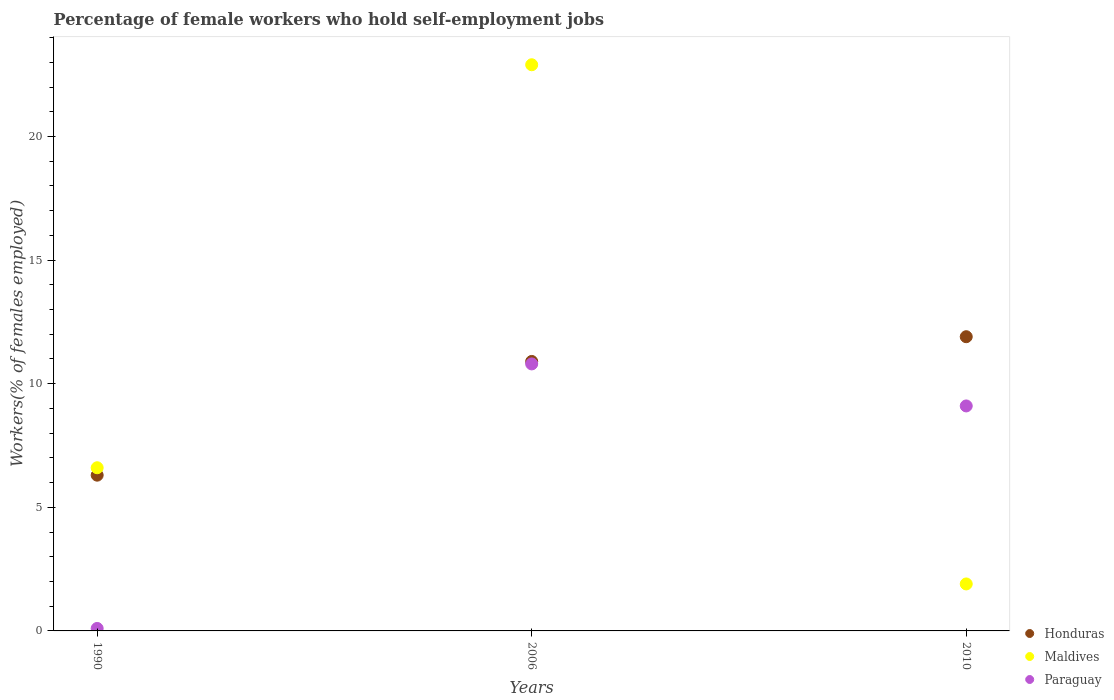What is the percentage of self-employed female workers in Paraguay in 2010?
Your answer should be very brief. 9.1. Across all years, what is the maximum percentage of self-employed female workers in Maldives?
Ensure brevity in your answer.  22.9. Across all years, what is the minimum percentage of self-employed female workers in Paraguay?
Keep it short and to the point. 0.1. In which year was the percentage of self-employed female workers in Paraguay maximum?
Make the answer very short. 2006. In which year was the percentage of self-employed female workers in Maldives minimum?
Your answer should be very brief. 2010. What is the total percentage of self-employed female workers in Paraguay in the graph?
Your answer should be compact. 20. What is the difference between the percentage of self-employed female workers in Maldives in 1990 and that in 2010?
Ensure brevity in your answer.  4.7. What is the difference between the percentage of self-employed female workers in Honduras in 2006 and the percentage of self-employed female workers in Paraguay in 2010?
Your answer should be compact. 1.8. What is the average percentage of self-employed female workers in Paraguay per year?
Provide a short and direct response. 6.67. In the year 1990, what is the difference between the percentage of self-employed female workers in Honduras and percentage of self-employed female workers in Paraguay?
Offer a very short reply. 6.2. What is the ratio of the percentage of self-employed female workers in Honduras in 1990 to that in 2006?
Your response must be concise. 0.58. What is the difference between the highest and the lowest percentage of self-employed female workers in Paraguay?
Offer a very short reply. 10.7. Is the sum of the percentage of self-employed female workers in Maldives in 1990 and 2006 greater than the maximum percentage of self-employed female workers in Paraguay across all years?
Keep it short and to the point. Yes. Is it the case that in every year, the sum of the percentage of self-employed female workers in Paraguay and percentage of self-employed female workers in Honduras  is greater than the percentage of self-employed female workers in Maldives?
Provide a short and direct response. No. Is the percentage of self-employed female workers in Honduras strictly greater than the percentage of self-employed female workers in Maldives over the years?
Give a very brief answer. No. Are the values on the major ticks of Y-axis written in scientific E-notation?
Make the answer very short. No. Does the graph contain any zero values?
Your answer should be very brief. No. Does the graph contain grids?
Ensure brevity in your answer.  No. Where does the legend appear in the graph?
Your answer should be very brief. Bottom right. How are the legend labels stacked?
Make the answer very short. Vertical. What is the title of the graph?
Provide a succinct answer. Percentage of female workers who hold self-employment jobs. What is the label or title of the X-axis?
Your answer should be very brief. Years. What is the label or title of the Y-axis?
Your response must be concise. Workers(% of females employed). What is the Workers(% of females employed) in Honduras in 1990?
Ensure brevity in your answer.  6.3. What is the Workers(% of females employed) of Maldives in 1990?
Your response must be concise. 6.6. What is the Workers(% of females employed) in Paraguay in 1990?
Provide a succinct answer. 0.1. What is the Workers(% of females employed) of Honduras in 2006?
Offer a very short reply. 10.9. What is the Workers(% of females employed) of Maldives in 2006?
Give a very brief answer. 22.9. What is the Workers(% of females employed) of Paraguay in 2006?
Provide a succinct answer. 10.8. What is the Workers(% of females employed) of Honduras in 2010?
Provide a succinct answer. 11.9. What is the Workers(% of females employed) of Maldives in 2010?
Offer a terse response. 1.9. What is the Workers(% of females employed) of Paraguay in 2010?
Your response must be concise. 9.1. Across all years, what is the maximum Workers(% of females employed) in Honduras?
Offer a terse response. 11.9. Across all years, what is the maximum Workers(% of females employed) of Maldives?
Your answer should be very brief. 22.9. Across all years, what is the maximum Workers(% of females employed) in Paraguay?
Your answer should be compact. 10.8. Across all years, what is the minimum Workers(% of females employed) in Honduras?
Keep it short and to the point. 6.3. Across all years, what is the minimum Workers(% of females employed) of Maldives?
Offer a very short reply. 1.9. Across all years, what is the minimum Workers(% of females employed) of Paraguay?
Give a very brief answer. 0.1. What is the total Workers(% of females employed) in Honduras in the graph?
Keep it short and to the point. 29.1. What is the total Workers(% of females employed) of Maldives in the graph?
Ensure brevity in your answer.  31.4. What is the total Workers(% of females employed) of Paraguay in the graph?
Offer a terse response. 20. What is the difference between the Workers(% of females employed) of Maldives in 1990 and that in 2006?
Provide a succinct answer. -16.3. What is the difference between the Workers(% of females employed) in Paraguay in 1990 and that in 2006?
Provide a succinct answer. -10.7. What is the difference between the Workers(% of females employed) in Paraguay in 1990 and that in 2010?
Provide a succinct answer. -9. What is the difference between the Workers(% of females employed) of Maldives in 2006 and that in 2010?
Offer a terse response. 21. What is the difference between the Workers(% of females employed) in Honduras in 1990 and the Workers(% of females employed) in Maldives in 2006?
Your response must be concise. -16.6. What is the difference between the Workers(% of females employed) in Honduras in 1990 and the Workers(% of females employed) in Paraguay in 2006?
Ensure brevity in your answer.  -4.5. What is the difference between the Workers(% of females employed) in Maldives in 1990 and the Workers(% of females employed) in Paraguay in 2006?
Give a very brief answer. -4.2. What is the difference between the Workers(% of females employed) of Honduras in 2006 and the Workers(% of females employed) of Maldives in 2010?
Provide a succinct answer. 9. What is the difference between the Workers(% of females employed) of Honduras in 2006 and the Workers(% of females employed) of Paraguay in 2010?
Your answer should be very brief. 1.8. What is the difference between the Workers(% of females employed) of Maldives in 2006 and the Workers(% of females employed) of Paraguay in 2010?
Ensure brevity in your answer.  13.8. What is the average Workers(% of females employed) of Maldives per year?
Offer a very short reply. 10.47. In the year 1990, what is the difference between the Workers(% of females employed) in Honduras and Workers(% of females employed) in Paraguay?
Keep it short and to the point. 6.2. In the year 2006, what is the difference between the Workers(% of females employed) in Honduras and Workers(% of females employed) in Maldives?
Give a very brief answer. -12. In the year 2006, what is the difference between the Workers(% of females employed) of Maldives and Workers(% of females employed) of Paraguay?
Ensure brevity in your answer.  12.1. In the year 2010, what is the difference between the Workers(% of females employed) in Honduras and Workers(% of females employed) in Paraguay?
Ensure brevity in your answer.  2.8. What is the ratio of the Workers(% of females employed) of Honduras in 1990 to that in 2006?
Give a very brief answer. 0.58. What is the ratio of the Workers(% of females employed) in Maldives in 1990 to that in 2006?
Provide a succinct answer. 0.29. What is the ratio of the Workers(% of females employed) in Paraguay in 1990 to that in 2006?
Your response must be concise. 0.01. What is the ratio of the Workers(% of females employed) in Honduras in 1990 to that in 2010?
Make the answer very short. 0.53. What is the ratio of the Workers(% of females employed) of Maldives in 1990 to that in 2010?
Give a very brief answer. 3.47. What is the ratio of the Workers(% of females employed) in Paraguay in 1990 to that in 2010?
Your answer should be very brief. 0.01. What is the ratio of the Workers(% of females employed) in Honduras in 2006 to that in 2010?
Give a very brief answer. 0.92. What is the ratio of the Workers(% of females employed) of Maldives in 2006 to that in 2010?
Ensure brevity in your answer.  12.05. What is the ratio of the Workers(% of females employed) of Paraguay in 2006 to that in 2010?
Provide a short and direct response. 1.19. What is the difference between the highest and the second highest Workers(% of females employed) of Honduras?
Offer a very short reply. 1. What is the difference between the highest and the second highest Workers(% of females employed) in Maldives?
Keep it short and to the point. 16.3. What is the difference between the highest and the second highest Workers(% of females employed) of Paraguay?
Keep it short and to the point. 1.7. 